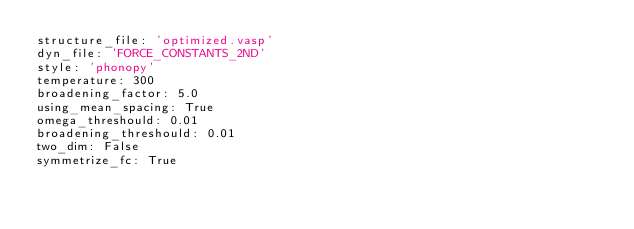<code> <loc_0><loc_0><loc_500><loc_500><_YAML_>structure_file: 'optimized.vasp'
dyn_file: 'FORCE_CONSTANTS_2ND'
style: 'phonopy'
temperature: 300
broadening_factor: 5.0
using_mean_spacing: True
omega_threshould: 0.01
broadening_threshould: 0.01
two_dim: False
symmetrize_fc: True</code> 